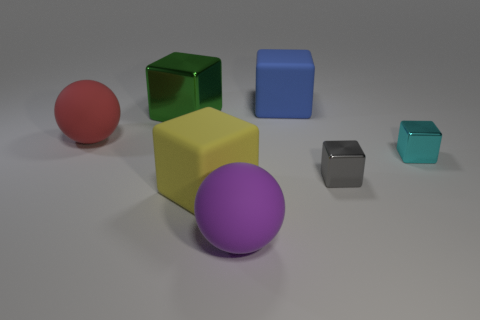Is the number of matte spheres that are to the right of the large purple rubber sphere greater than the number of cyan metal cubes?
Your answer should be very brief. No. What number of objects are either large brown matte spheres or large green things?
Your answer should be compact. 1. What color is the big shiny object?
Offer a terse response. Green. How many other objects are there of the same color as the big metallic block?
Ensure brevity in your answer.  0. Are there any gray metallic things left of the big purple sphere?
Your answer should be very brief. No. What is the color of the metallic object behind the large red matte ball that is in front of the rubber object that is right of the purple matte sphere?
Your answer should be very brief. Green. How many objects are left of the large purple ball and right of the big red thing?
Provide a short and direct response. 2. What number of cylinders are large yellow matte objects or tiny cyan shiny things?
Your answer should be compact. 0. Are there any big brown things?
Provide a short and direct response. No. What number of other objects are there of the same material as the big yellow thing?
Your answer should be compact. 3. 